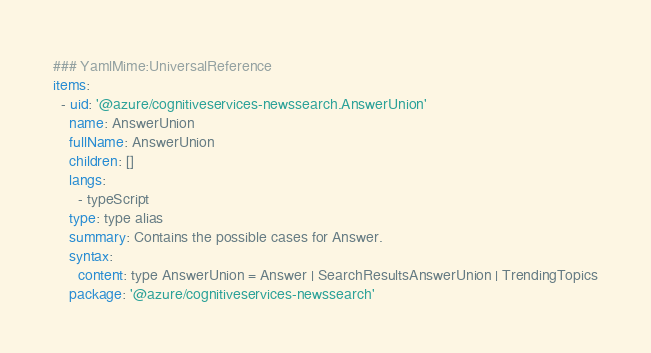<code> <loc_0><loc_0><loc_500><loc_500><_YAML_>### YamlMime:UniversalReference
items:
  - uid: '@azure/cognitiveservices-newssearch.AnswerUnion'
    name: AnswerUnion
    fullName: AnswerUnion
    children: []
    langs:
      - typeScript
    type: type alias
    summary: Contains the possible cases for Answer.
    syntax:
      content: type AnswerUnion = Answer | SearchResultsAnswerUnion | TrendingTopics
    package: '@azure/cognitiveservices-newssearch'
</code> 